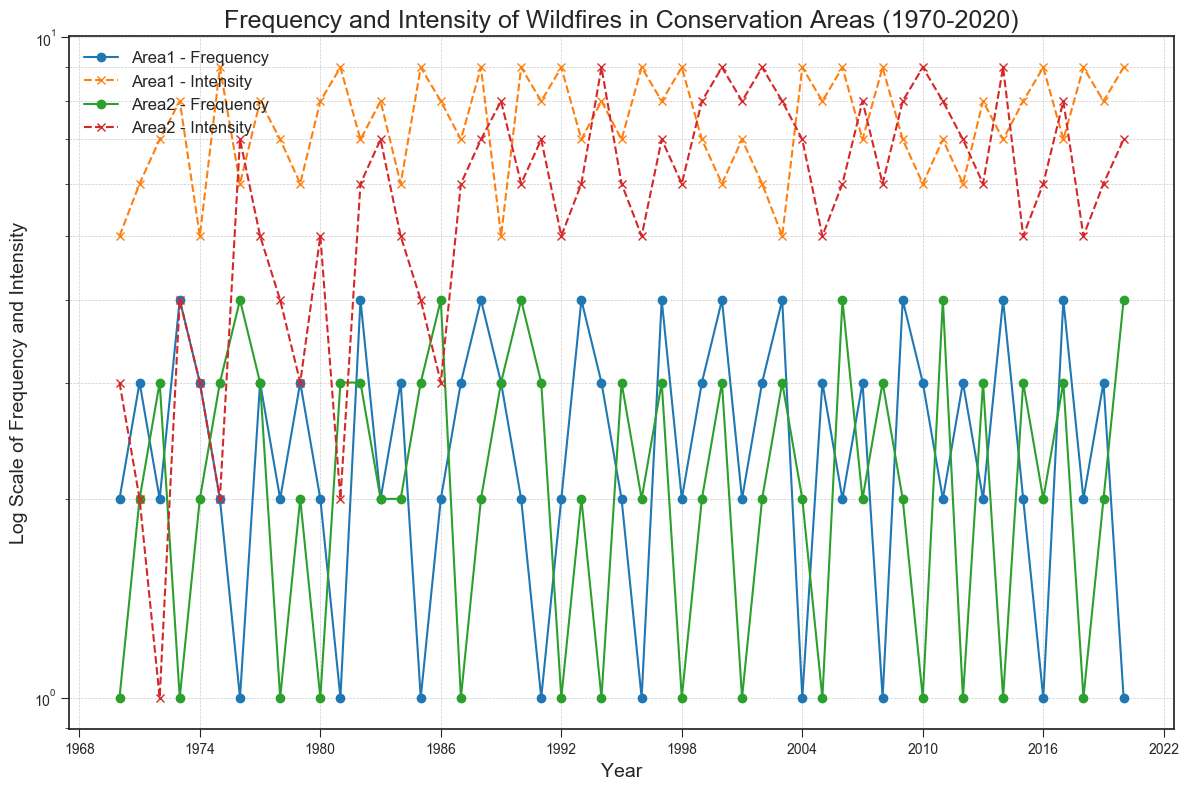What is the overall trend in wildfire intensity in Area1 over the years? To determine the trend, we observe the line representing the intensity levels for Area1 from 1970 to 2020. Despite some fluctuations, the pattern largely shows that the intensity values remain high overall, indicating that intensity is consistently high.
Answer: Consistently high Which conservation area experienced the higher frequency of wildfires in 1990? Look at the points for the frequency lines of both areas in the year 1990. For Area1, the frequency is 2, and for Area2, the frequency is 4.
Answer: Area2 Calculate the average wildfire intensity in Area2 during the 2000s (2000-2009). Identify the intensity values for Area2 each year from 2000 to 2009: 9, 8, 9, 8, 7, 5, 6, 8, 8, 9. Sum these values: 9 + 8 + 9 + 8 + 7 + 5 + 6 + 8 + 8 + 9 = 77. There are 10 values, so the average is 77 / 10 = 7.7.
Answer: 7.7 Comparing the frequency of wildfires in 1985 and 2000 for Area1, which year had a higher frequency? For Area1, the frequency in 1985 is 1 and in 2000 it is 4. Clearly, 2000 had a higher frequency.
Answer: 2000 What is the difference in wildfire intensity between Area1 and Area2 in 2015? For 2015, the intensity for Area1 is 8 and for Area2 is 5. The difference is 8 - 5 = 3.
Answer: 3 In which year did Area1 reach its peak wildfire frequency, and what was the corresponding intensity that year? Look for the highest point in frequency for Area1, which is 4. This occurs in 1973, 1982, 1988, 1993, 1997, 2000, 2009, 2014, and 2017. We check the corresponding intensity for these years. All these years have different intensities. The correct value is the highest point, which intensity is recorded in 1973 (8).
Answer: 1973, 8 Which conservation area showed more variability in wildfire frequency over the five decades? Visual comparison of the fluctuation in frequency lines for both areas shows more significant ups and downs in Area2's line, indicating more variability.
Answer: Area2 What was the wildfire frequency pattern of Area2 between 1980-1985? From the figure, examine the frequency points for Area2 from 1980 to 1985. These values are 1 (1980), 3 (1981), 3 (1982), 2 (1983), 2 (1984), and 3 (1985). The pattern is a relatively stable fluctuation between 1 and 3.
Answer: Stable fluctuation between 1 and 3 How does the intensity trend in Area2 compare to Area1 from 1995 to 2000? Examine the intensity lines for both areas between 1995 and 2000. The intensity in Area2 shows a decreasing trend followed by an increase (from 6 to 9), whereas Area1 maintains a consistently high intensity (ranging from 7 to 9).
Answer: Area1 consistent, Area2 fluctuating 